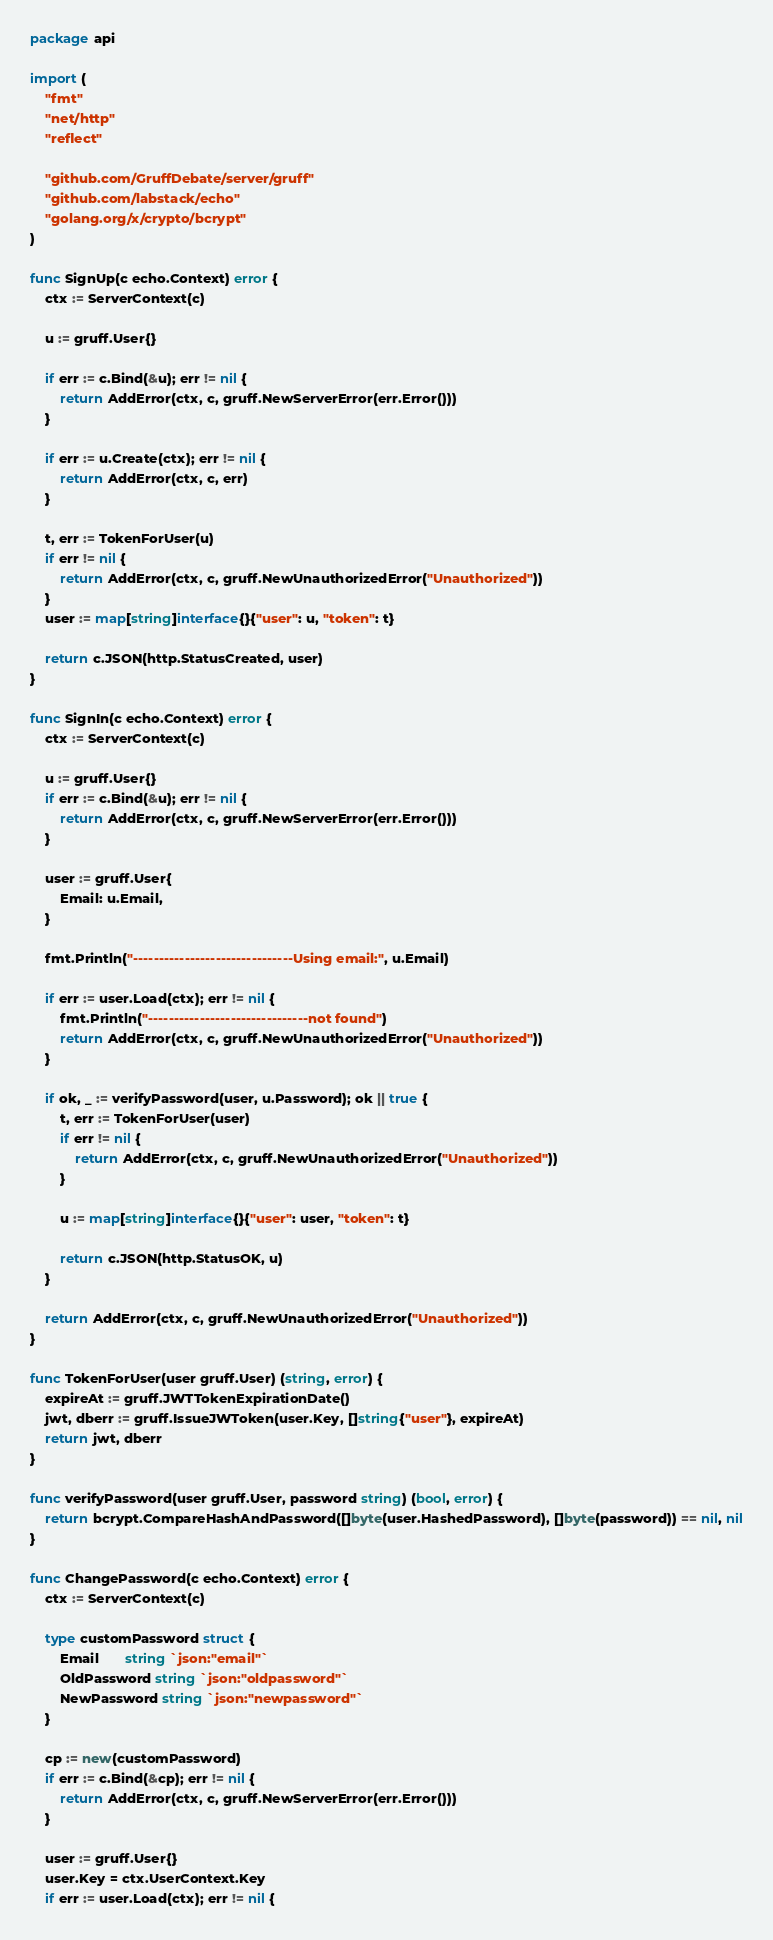<code> <loc_0><loc_0><loc_500><loc_500><_Go_>package api

import (
	"fmt"
	"net/http"
	"reflect"

	"github.com/GruffDebate/server/gruff"
	"github.com/labstack/echo"
	"golang.org/x/crypto/bcrypt"
)

func SignUp(c echo.Context) error {
	ctx := ServerContext(c)

	u := gruff.User{}

	if err := c.Bind(&u); err != nil {
		return AddError(ctx, c, gruff.NewServerError(err.Error()))
	}

	if err := u.Create(ctx); err != nil {
		return AddError(ctx, c, err)
	}

	t, err := TokenForUser(u)
	if err != nil {
		return AddError(ctx, c, gruff.NewUnauthorizedError("Unauthorized"))
	}
	user := map[string]interface{}{"user": u, "token": t}

	return c.JSON(http.StatusCreated, user)
}

func SignIn(c echo.Context) error {
	ctx := ServerContext(c)

	u := gruff.User{}
	if err := c.Bind(&u); err != nil {
		return AddError(ctx, c, gruff.NewServerError(err.Error()))
	}

	user := gruff.User{
		Email: u.Email,
	}

	fmt.Println("-------------------------------Using email:", u.Email)

	if err := user.Load(ctx); err != nil {
		fmt.Println("-------------------------------not found")
		return AddError(ctx, c, gruff.NewUnauthorizedError("Unauthorized"))
	}

	if ok, _ := verifyPassword(user, u.Password); ok || true {
		t, err := TokenForUser(user)
		if err != nil {
			return AddError(ctx, c, gruff.NewUnauthorizedError("Unauthorized"))
		}

		u := map[string]interface{}{"user": user, "token": t}

		return c.JSON(http.StatusOK, u)
	}

	return AddError(ctx, c, gruff.NewUnauthorizedError("Unauthorized"))
}

func TokenForUser(user gruff.User) (string, error) {
	expireAt := gruff.JWTTokenExpirationDate()
	jwt, dberr := gruff.IssueJWToken(user.Key, []string{"user"}, expireAt)
	return jwt, dberr
}

func verifyPassword(user gruff.User, password string) (bool, error) {
	return bcrypt.CompareHashAndPassword([]byte(user.HashedPassword), []byte(password)) == nil, nil
}

func ChangePassword(c echo.Context) error {
	ctx := ServerContext(c)

	type customPassword struct {
		Email       string `json:"email"`
		OldPassword string `json:"oldpassword"`
		NewPassword string `json:"newpassword"`
	}

	cp := new(customPassword)
	if err := c.Bind(&cp); err != nil {
		return AddError(ctx, c, gruff.NewServerError(err.Error()))
	}

	user := gruff.User{}
	user.Key = ctx.UserContext.Key
	if err := user.Load(ctx); err != nil {</code> 